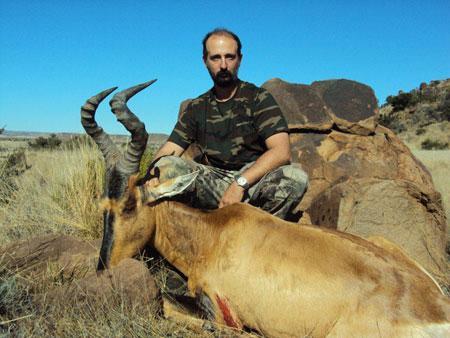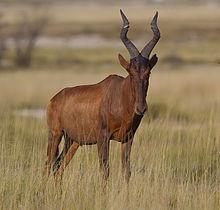The first image is the image on the left, the second image is the image on the right. Analyze the images presented: Is the assertion "One of the images contains one man with a dead antelope." valid? Answer yes or no. Yes. The first image is the image on the left, the second image is the image on the right. Analyze the images presented: Is the assertion "Just one hunter crouches behind a downed antelope in one of the images." valid? Answer yes or no. Yes. 